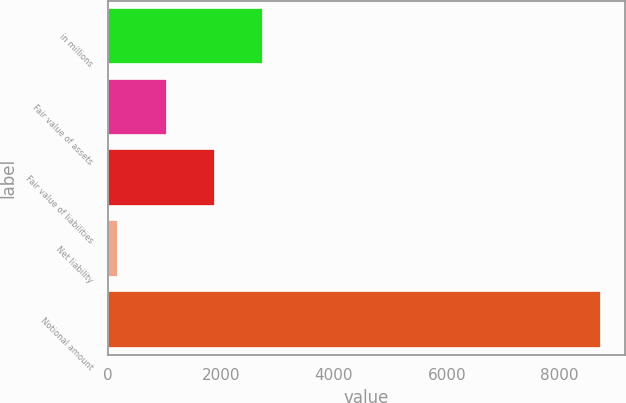Convert chart. <chart><loc_0><loc_0><loc_500><loc_500><bar_chart><fcel>in millions<fcel>Fair value of assets<fcel>Fair value of liabilities<fcel>Net liability<fcel>Notional amount<nl><fcel>2749.4<fcel>1041.8<fcel>1895.6<fcel>188<fcel>8726<nl></chart> 